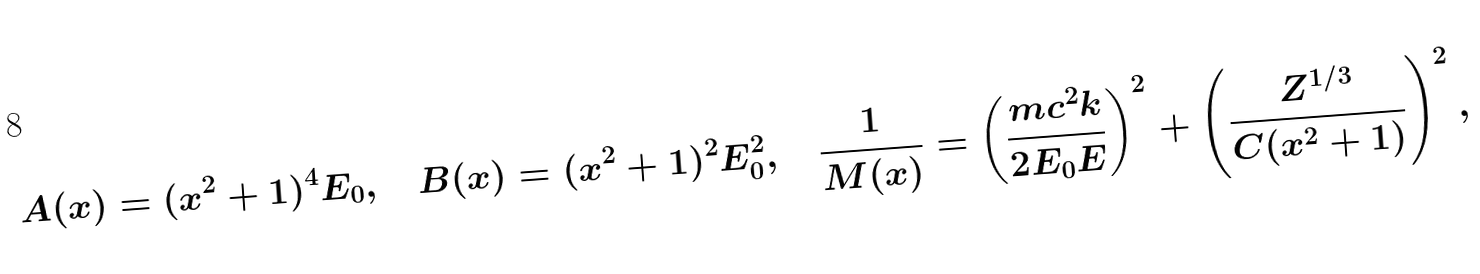<formula> <loc_0><loc_0><loc_500><loc_500>A ( x ) = ( x ^ { 2 } + 1 ) ^ { 4 } E _ { 0 } , \quad B ( x ) = ( x ^ { 2 } + 1 ) ^ { 2 } E _ { 0 } ^ { 2 } , \quad \frac { 1 } { M ( x ) } = \left ( \frac { m c ^ { 2 } k } { 2 E _ { 0 } E } \right ) ^ { 2 } + \left ( \frac { Z ^ { 1 / 3 } } { C ( x ^ { 2 } + 1 ) } \right ) ^ { 2 } ,</formula> 